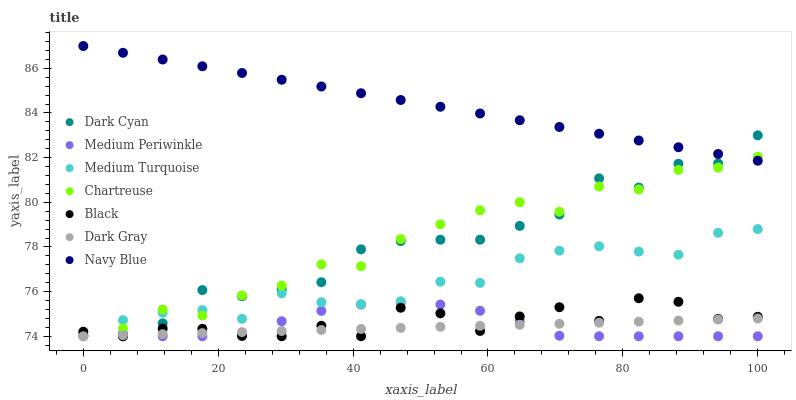Does Dark Gray have the minimum area under the curve?
Answer yes or no. Yes. Does Navy Blue have the maximum area under the curve?
Answer yes or no. Yes. Does Medium Periwinkle have the minimum area under the curve?
Answer yes or no. No. Does Medium Periwinkle have the maximum area under the curve?
Answer yes or no. No. Is Dark Gray the smoothest?
Answer yes or no. Yes. Is Dark Cyan the roughest?
Answer yes or no. Yes. Is Medium Periwinkle the smoothest?
Answer yes or no. No. Is Medium Periwinkle the roughest?
Answer yes or no. No. Does Medium Periwinkle have the lowest value?
Answer yes or no. Yes. Does Dark Cyan have the lowest value?
Answer yes or no. No. Does Navy Blue have the highest value?
Answer yes or no. Yes. Does Medium Periwinkle have the highest value?
Answer yes or no. No. Is Dark Gray less than Dark Cyan?
Answer yes or no. Yes. Is Navy Blue greater than Dark Gray?
Answer yes or no. Yes. Does Dark Gray intersect Chartreuse?
Answer yes or no. Yes. Is Dark Gray less than Chartreuse?
Answer yes or no. No. Is Dark Gray greater than Chartreuse?
Answer yes or no. No. Does Dark Gray intersect Dark Cyan?
Answer yes or no. No. 